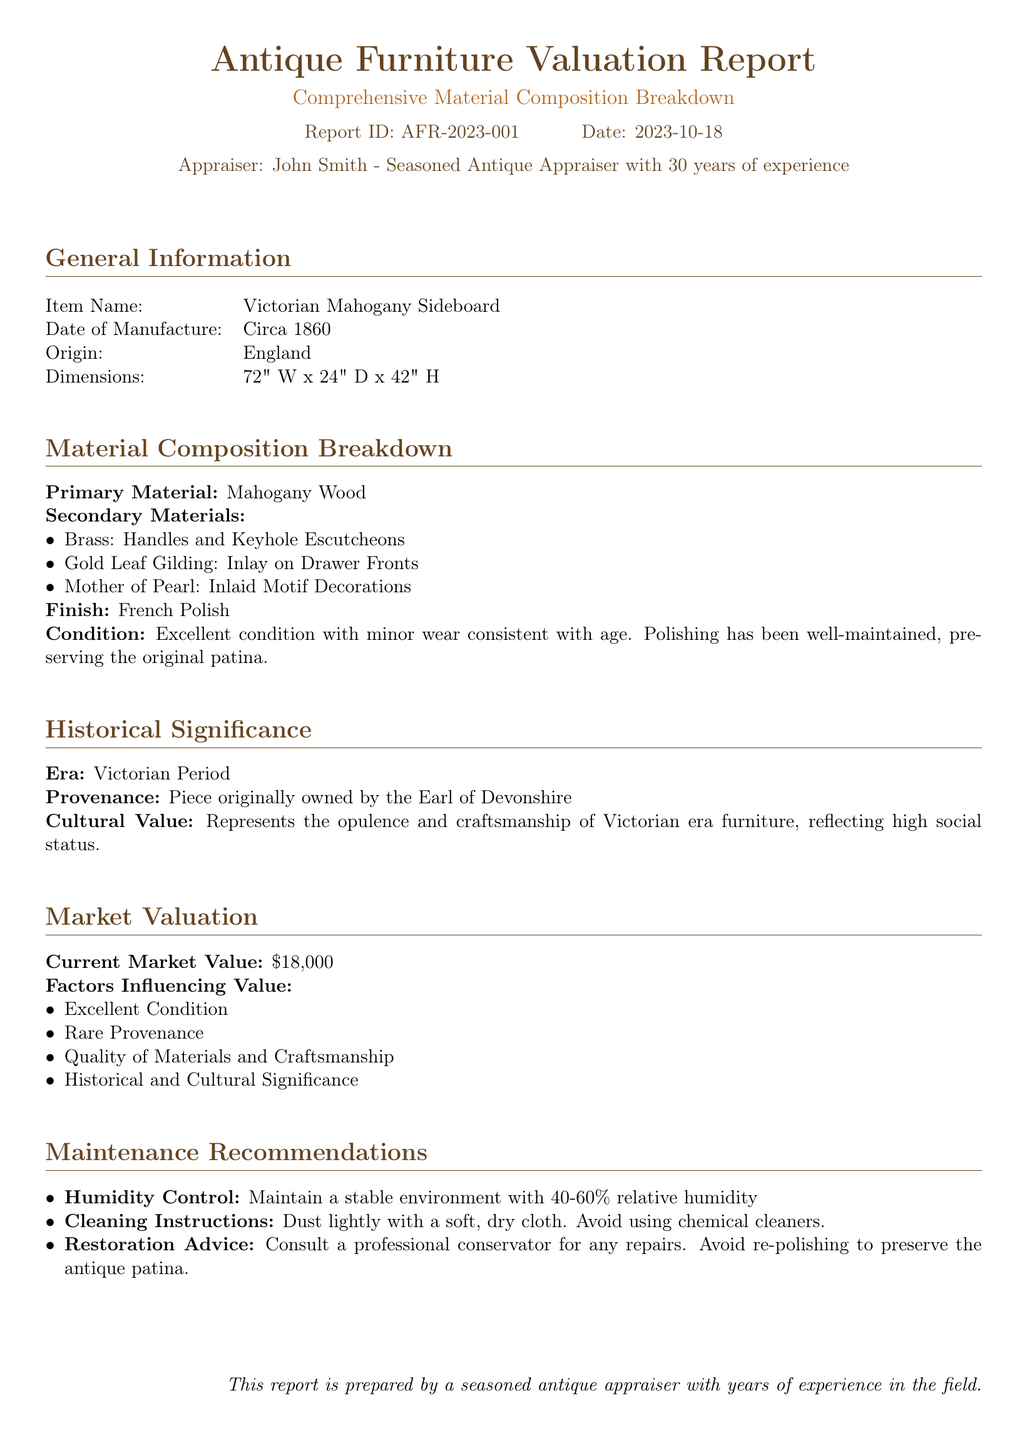What is the item name? The item name is located in the General Information section of the document.
Answer: Victorian Mahogany Sideboard What is the date of manufacture? The date of manufacture is found under the General Information section.
Answer: Circa 1860 What is the current market value? The current market value is provided in the Market Valuation section of the document.
Answer: $18,000 What materials are used for the handles? The secondary materials section lists the components of the item, including the material for handles.
Answer: Brass What is the finish of the sideboard? The finish information is mentioned in the Material Composition Breakdown section.
Answer: French Polish What are the maintenance recommendations regarding humidity? The maintenance section includes specific recommendations for humidity levels.
Answer: Maintain a stable environment with 40-60% relative humidity What does the provenance indicate? The provenance details provide historical context regarding prior ownership.
Answer: Piece originally owned by the Earl of Devonshire Why is the market value high? Factors influencing the market value include multiple aspects of the item noted in the Market Valuation section.
Answer: Excellent Condition, Rare Provenance, Quality of Materials and Craftsmanship, Historical and Cultural Significance What era does the piece represent? The era is specified in the Historical Significance section of the report.
Answer: Victorian Period 